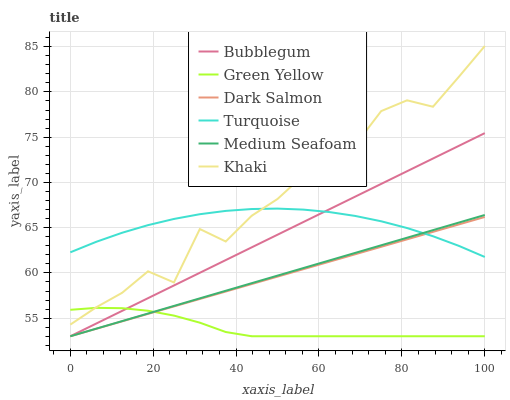Does Green Yellow have the minimum area under the curve?
Answer yes or no. Yes. Does Khaki have the maximum area under the curve?
Answer yes or no. Yes. Does Dark Salmon have the minimum area under the curve?
Answer yes or no. No. Does Dark Salmon have the maximum area under the curve?
Answer yes or no. No. Is Dark Salmon the smoothest?
Answer yes or no. Yes. Is Khaki the roughest?
Answer yes or no. Yes. Is Khaki the smoothest?
Answer yes or no. No. Is Dark Salmon the roughest?
Answer yes or no. No. Does Dark Salmon have the lowest value?
Answer yes or no. Yes. Does Khaki have the lowest value?
Answer yes or no. No. Does Khaki have the highest value?
Answer yes or no. Yes. Does Dark Salmon have the highest value?
Answer yes or no. No. Is Bubblegum less than Khaki?
Answer yes or no. Yes. Is Turquoise greater than Green Yellow?
Answer yes or no. Yes. Does Medium Seafoam intersect Turquoise?
Answer yes or no. Yes. Is Medium Seafoam less than Turquoise?
Answer yes or no. No. Is Medium Seafoam greater than Turquoise?
Answer yes or no. No. Does Bubblegum intersect Khaki?
Answer yes or no. No. 